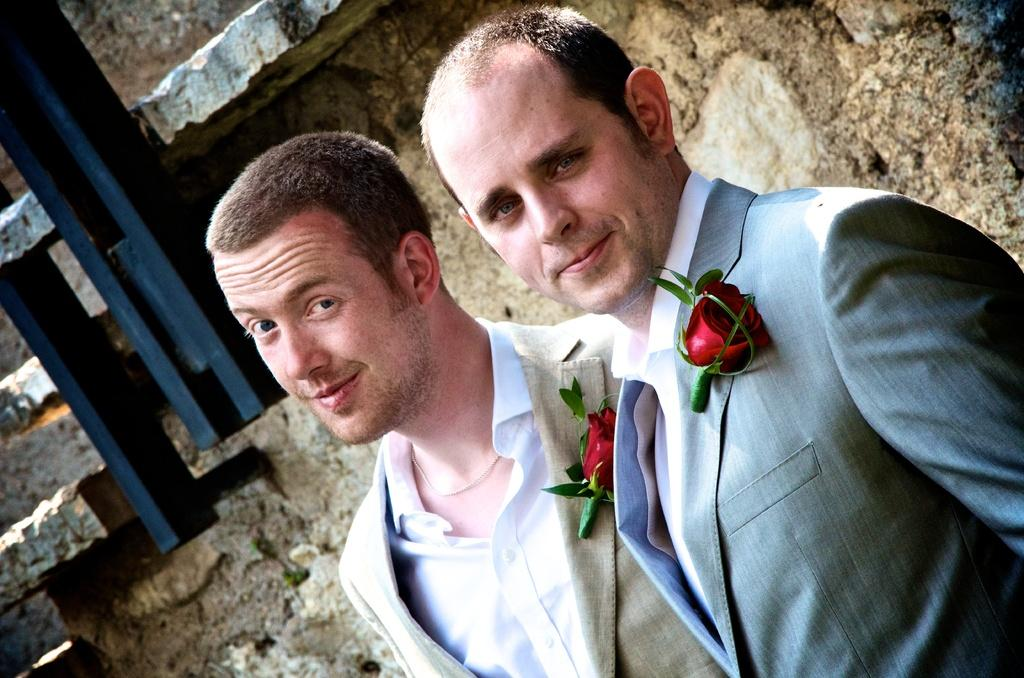How many people are in the image? There are two persons standing in the image. What are the persons wearing? The persons are wearing blazers with roses on them. What can be seen in the background of the image? There is a pole and a wall visible in the background of the image. What type of fowl can be seen perched on the pole in the image? There is no fowl present in the image; only the pole and the wall are visible in the background. How many beads are hanging from the wall in the image? There is no mention of beads in the image; the wall is simply a background element. 